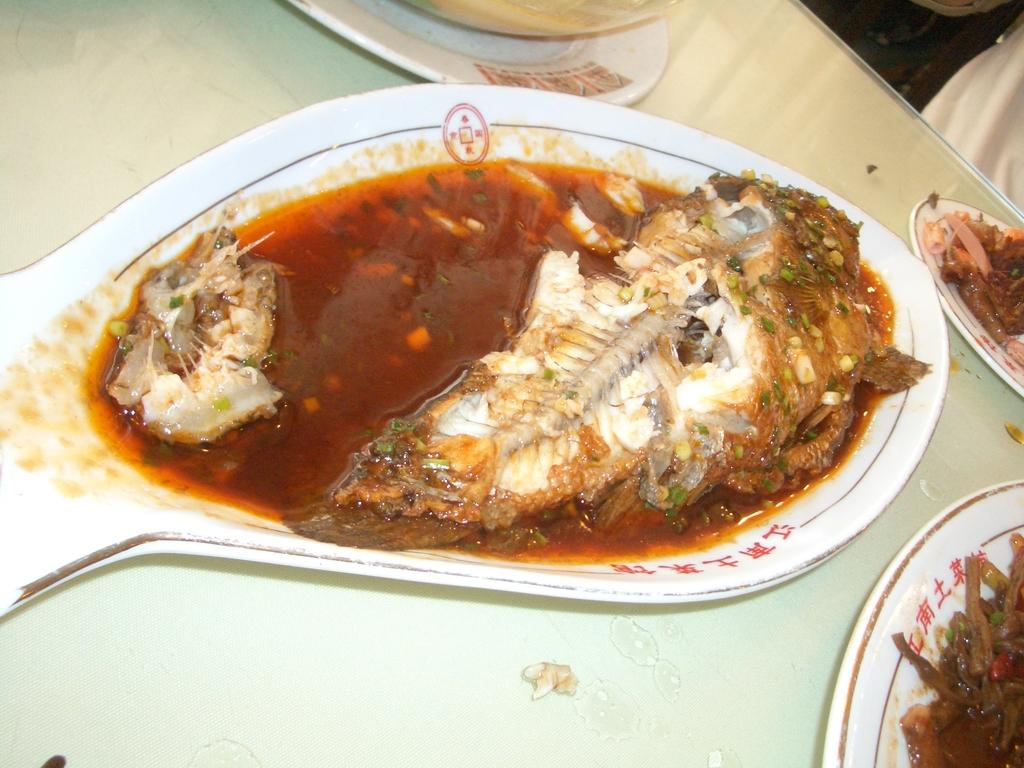What is present on the plates in the image? There are food items on plates in the image. Where are the plates with food items located? The plates are on a table. What type of haircut is the food receiving in the image? There is no haircut present in the image, as the image features food items on plates. 